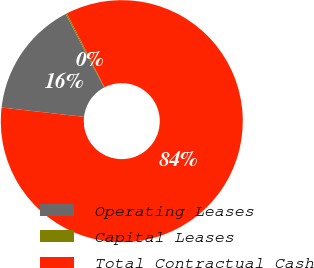Convert chart to OTSL. <chart><loc_0><loc_0><loc_500><loc_500><pie_chart><fcel>Operating Leases<fcel>Capital Leases<fcel>Total Contractual Cash<nl><fcel>15.52%<fcel>0.18%<fcel>84.3%<nl></chart> 